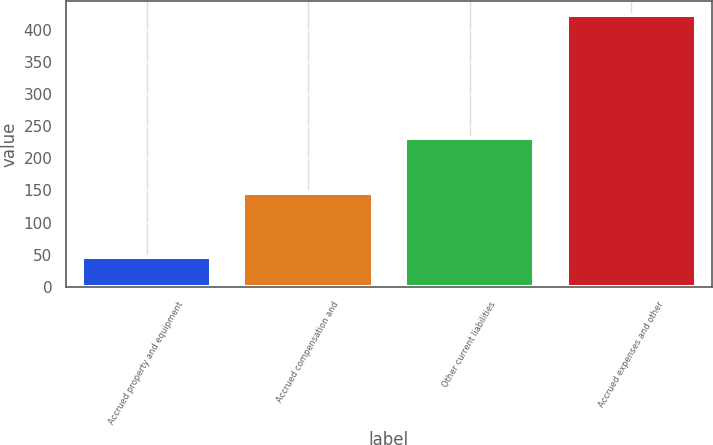<chart> <loc_0><loc_0><loc_500><loc_500><bar_chart><fcel>Accrued property and equipment<fcel>Accrued compensation and<fcel>Other current liabilities<fcel>Accrued expenses and other<nl><fcel>46<fcel>146<fcel>231<fcel>423<nl></chart> 